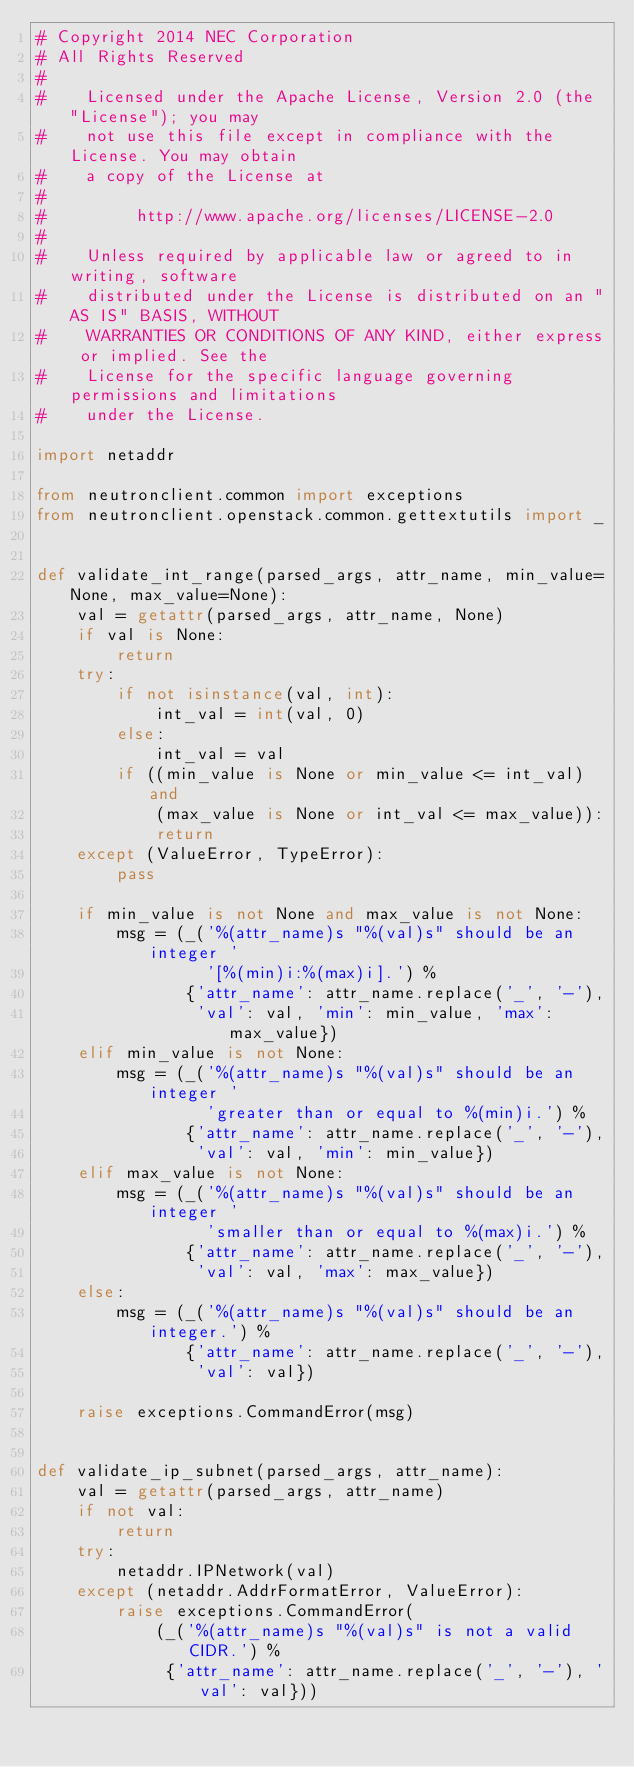Convert code to text. <code><loc_0><loc_0><loc_500><loc_500><_Python_># Copyright 2014 NEC Corporation
# All Rights Reserved
#
#    Licensed under the Apache License, Version 2.0 (the "License"); you may
#    not use this file except in compliance with the License. You may obtain
#    a copy of the License at
#
#         http://www.apache.org/licenses/LICENSE-2.0
#
#    Unless required by applicable law or agreed to in writing, software
#    distributed under the License is distributed on an "AS IS" BASIS, WITHOUT
#    WARRANTIES OR CONDITIONS OF ANY KIND, either express or implied. See the
#    License for the specific language governing permissions and limitations
#    under the License.

import netaddr

from neutronclient.common import exceptions
from neutronclient.openstack.common.gettextutils import _


def validate_int_range(parsed_args, attr_name, min_value=None, max_value=None):
    val = getattr(parsed_args, attr_name, None)
    if val is None:
        return
    try:
        if not isinstance(val, int):
            int_val = int(val, 0)
        else:
            int_val = val
        if ((min_value is None or min_value <= int_val) and
            (max_value is None or int_val <= max_value)):
            return
    except (ValueError, TypeError):
        pass

    if min_value is not None and max_value is not None:
        msg = (_('%(attr_name)s "%(val)s" should be an integer '
                 '[%(min)i:%(max)i].') %
               {'attr_name': attr_name.replace('_', '-'),
                'val': val, 'min': min_value, 'max': max_value})
    elif min_value is not None:
        msg = (_('%(attr_name)s "%(val)s" should be an integer '
                 'greater than or equal to %(min)i.') %
               {'attr_name': attr_name.replace('_', '-'),
                'val': val, 'min': min_value})
    elif max_value is not None:
        msg = (_('%(attr_name)s "%(val)s" should be an integer '
                 'smaller than or equal to %(max)i.') %
               {'attr_name': attr_name.replace('_', '-'),
                'val': val, 'max': max_value})
    else:
        msg = (_('%(attr_name)s "%(val)s" should be an integer.') %
               {'attr_name': attr_name.replace('_', '-'),
                'val': val})

    raise exceptions.CommandError(msg)


def validate_ip_subnet(parsed_args, attr_name):
    val = getattr(parsed_args, attr_name)
    if not val:
        return
    try:
        netaddr.IPNetwork(val)
    except (netaddr.AddrFormatError, ValueError):
        raise exceptions.CommandError(
            (_('%(attr_name)s "%(val)s" is not a valid CIDR.') %
             {'attr_name': attr_name.replace('_', '-'), 'val': val}))
</code> 